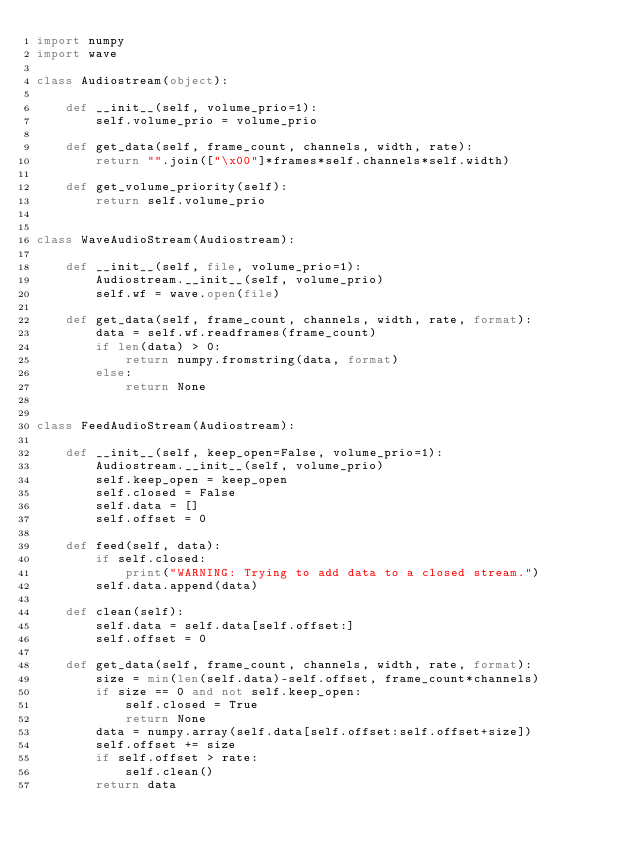Convert code to text. <code><loc_0><loc_0><loc_500><loc_500><_Python_>import numpy
import wave
        
class Audiostream(object):
    
    def __init__(self, volume_prio=1):
        self.volume_prio = volume_prio
        
    def get_data(self, frame_count, channels, width, rate):
        return "".join(["\x00"]*frames*self.channels*self.width)
        
    def get_volume_priority(self):
        return self.volume_prio
        
        
class WaveAudioStream(Audiostream):
    
    def __init__(self, file, volume_prio=1):
        Audiostream.__init__(self, volume_prio)
        self.wf = wave.open(file)
        
    def get_data(self, frame_count, channels, width, rate, format):
        data = self.wf.readframes(frame_count)
        if len(data) > 0:
            return numpy.fromstring(data, format)
        else:
            return None
            
            
class FeedAudioStream(Audiostream):
    
    def __init__(self, keep_open=False, volume_prio=1):
        Audiostream.__init__(self, volume_prio)
        self.keep_open = keep_open
        self.closed = False
        self.data = []
        self.offset = 0
        
    def feed(self, data):
        if self.closed:
            print("WARNING: Trying to add data to a closed stream.")
        self.data.append(data)
        
    def clean(self):
        self.data = self.data[self.offset:]
        self.offset = 0
        
    def get_data(self, frame_count, channels, width, rate, format):
        size = min(len(self.data)-self.offset, frame_count*channels)
        if size == 0 and not self.keep_open:
            self.closed = True
            return None
        data = numpy.array(self.data[self.offset:self.offset+size])
        self.offset += size
        if self.offset > rate:
            self.clean()
        return data
            </code> 